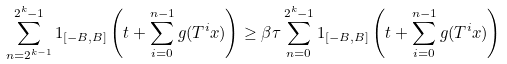<formula> <loc_0><loc_0><loc_500><loc_500>\sum _ { n = 2 ^ { k - 1 } } ^ { 2 ^ { k } - 1 } 1 _ { [ - B , B ] } \left ( t + \sum _ { i = 0 } ^ { n - 1 } g ( T ^ { i } x ) \right ) \geq \beta \tau \sum _ { n = 0 } ^ { 2 ^ { k } - 1 } 1 _ { [ - B , B ] } \left ( t + \sum _ { i = 0 } ^ { n - 1 } g ( T ^ { i } x ) \right )</formula> 